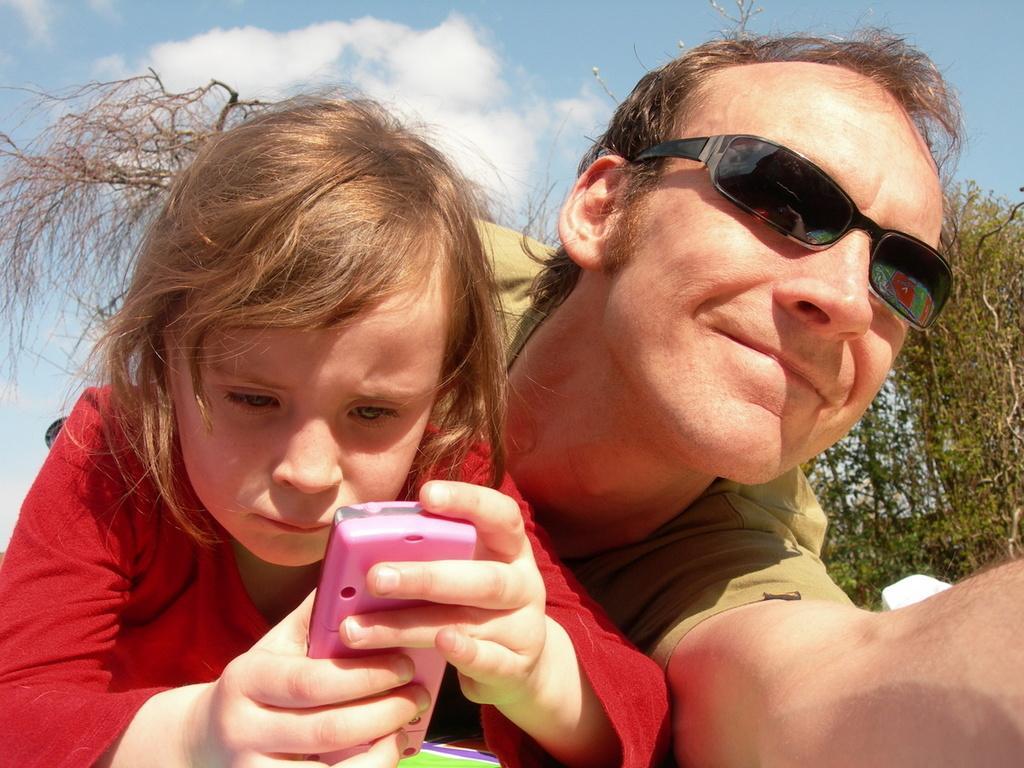Can you describe this image briefly? There is one man wearing black color goggles in the middle of this image, and there is one girl holding a mobile on the left side of this image. There are some trees on the right side of this image, and there is a cloudy sky in the background. 